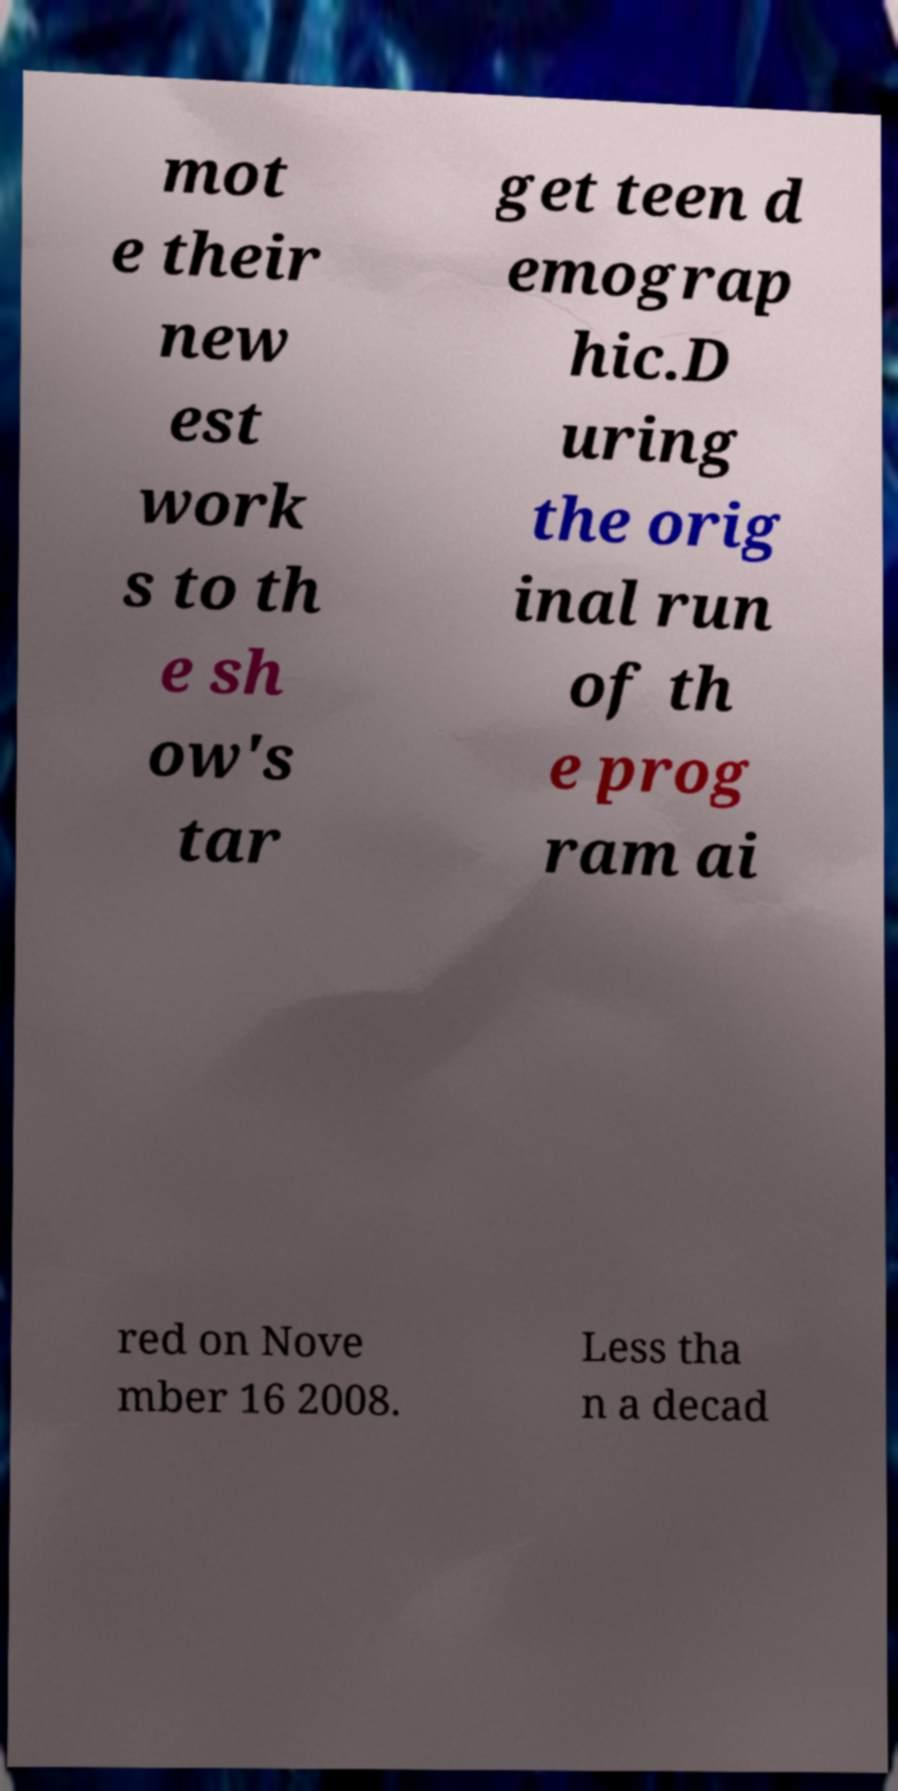Can you accurately transcribe the text from the provided image for me? mot e their new est work s to th e sh ow's tar get teen d emograp hic.D uring the orig inal run of th e prog ram ai red on Nove mber 16 2008. Less tha n a decad 